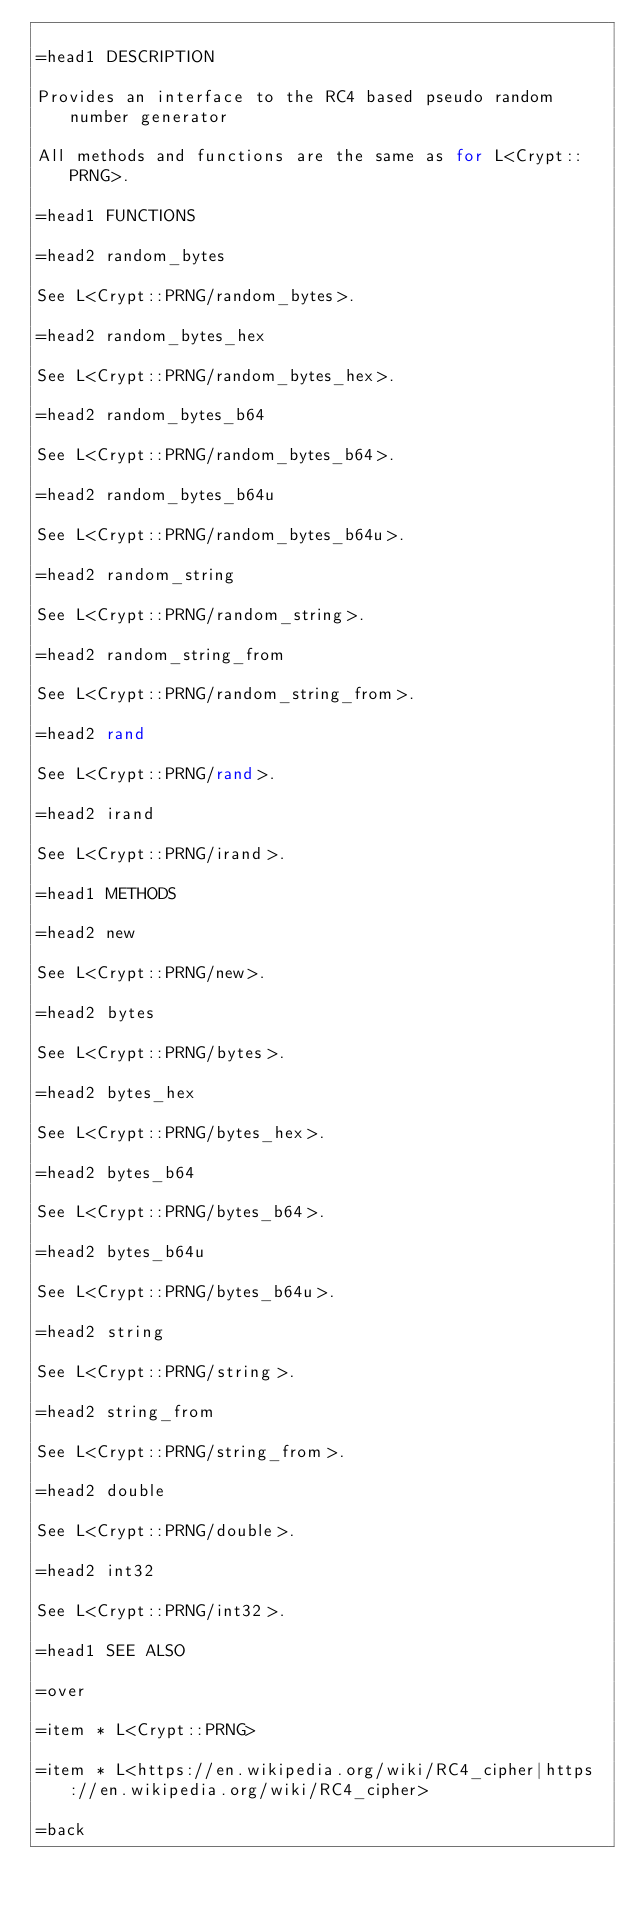<code> <loc_0><loc_0><loc_500><loc_500><_Perl_>
=head1 DESCRIPTION

Provides an interface to the RC4 based pseudo random number generator

All methods and functions are the same as for L<Crypt::PRNG>.

=head1 FUNCTIONS

=head2 random_bytes

See L<Crypt::PRNG/random_bytes>.

=head2 random_bytes_hex

See L<Crypt::PRNG/random_bytes_hex>.

=head2 random_bytes_b64

See L<Crypt::PRNG/random_bytes_b64>.

=head2 random_bytes_b64u

See L<Crypt::PRNG/random_bytes_b64u>.

=head2 random_string

See L<Crypt::PRNG/random_string>.

=head2 random_string_from

See L<Crypt::PRNG/random_string_from>.

=head2 rand

See L<Crypt::PRNG/rand>.

=head2 irand

See L<Crypt::PRNG/irand>.

=head1 METHODS

=head2 new

See L<Crypt::PRNG/new>.

=head2 bytes

See L<Crypt::PRNG/bytes>.

=head2 bytes_hex

See L<Crypt::PRNG/bytes_hex>.

=head2 bytes_b64

See L<Crypt::PRNG/bytes_b64>.

=head2 bytes_b64u

See L<Crypt::PRNG/bytes_b64u>.

=head2 string

See L<Crypt::PRNG/string>.

=head2 string_from

See L<Crypt::PRNG/string_from>.

=head2 double

See L<Crypt::PRNG/double>.

=head2 int32

See L<Crypt::PRNG/int32>.

=head1 SEE ALSO

=over

=item * L<Crypt::PRNG>

=item * L<https://en.wikipedia.org/wiki/RC4_cipher|https://en.wikipedia.org/wiki/RC4_cipher>

=back
</code> 